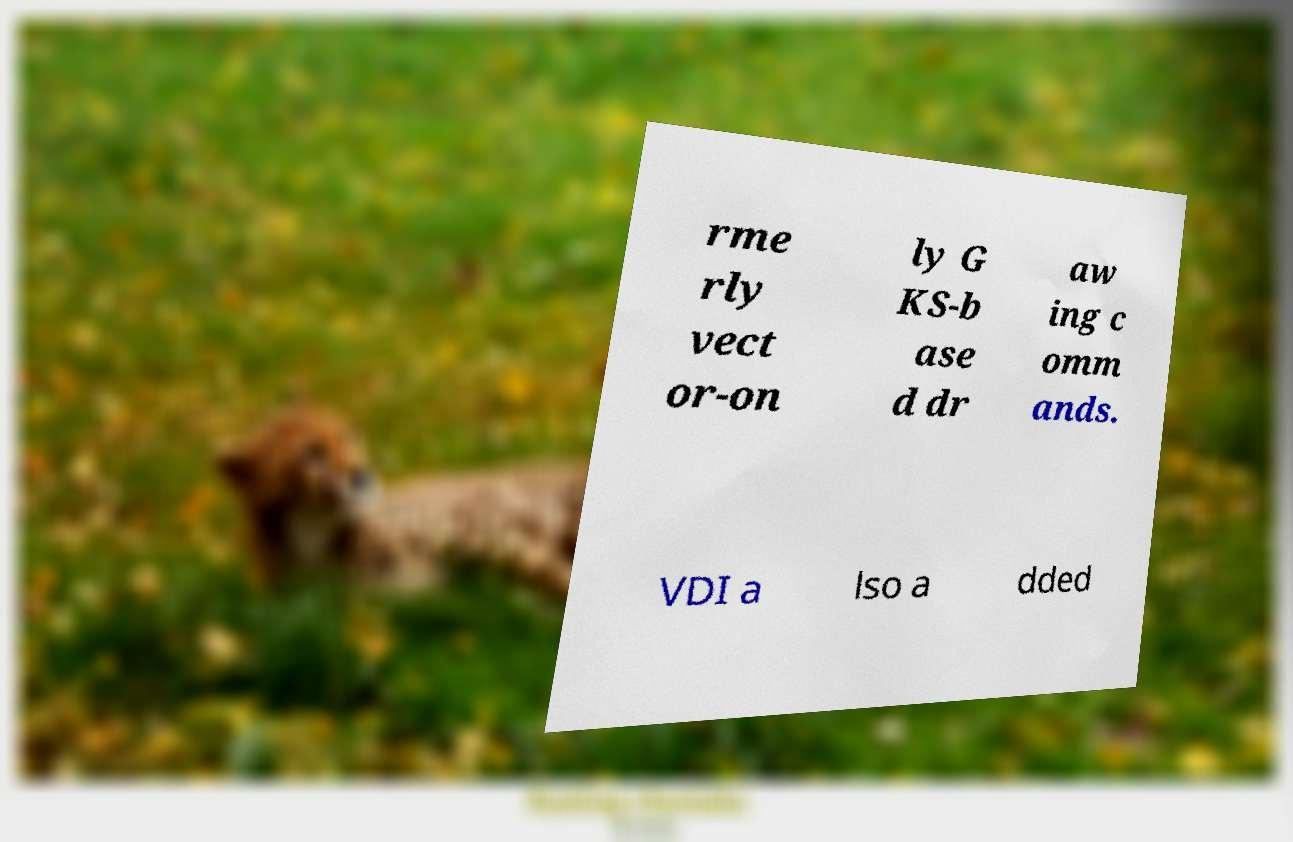Can you read and provide the text displayed in the image?This photo seems to have some interesting text. Can you extract and type it out for me? rme rly vect or-on ly G KS-b ase d dr aw ing c omm ands. VDI a lso a dded 